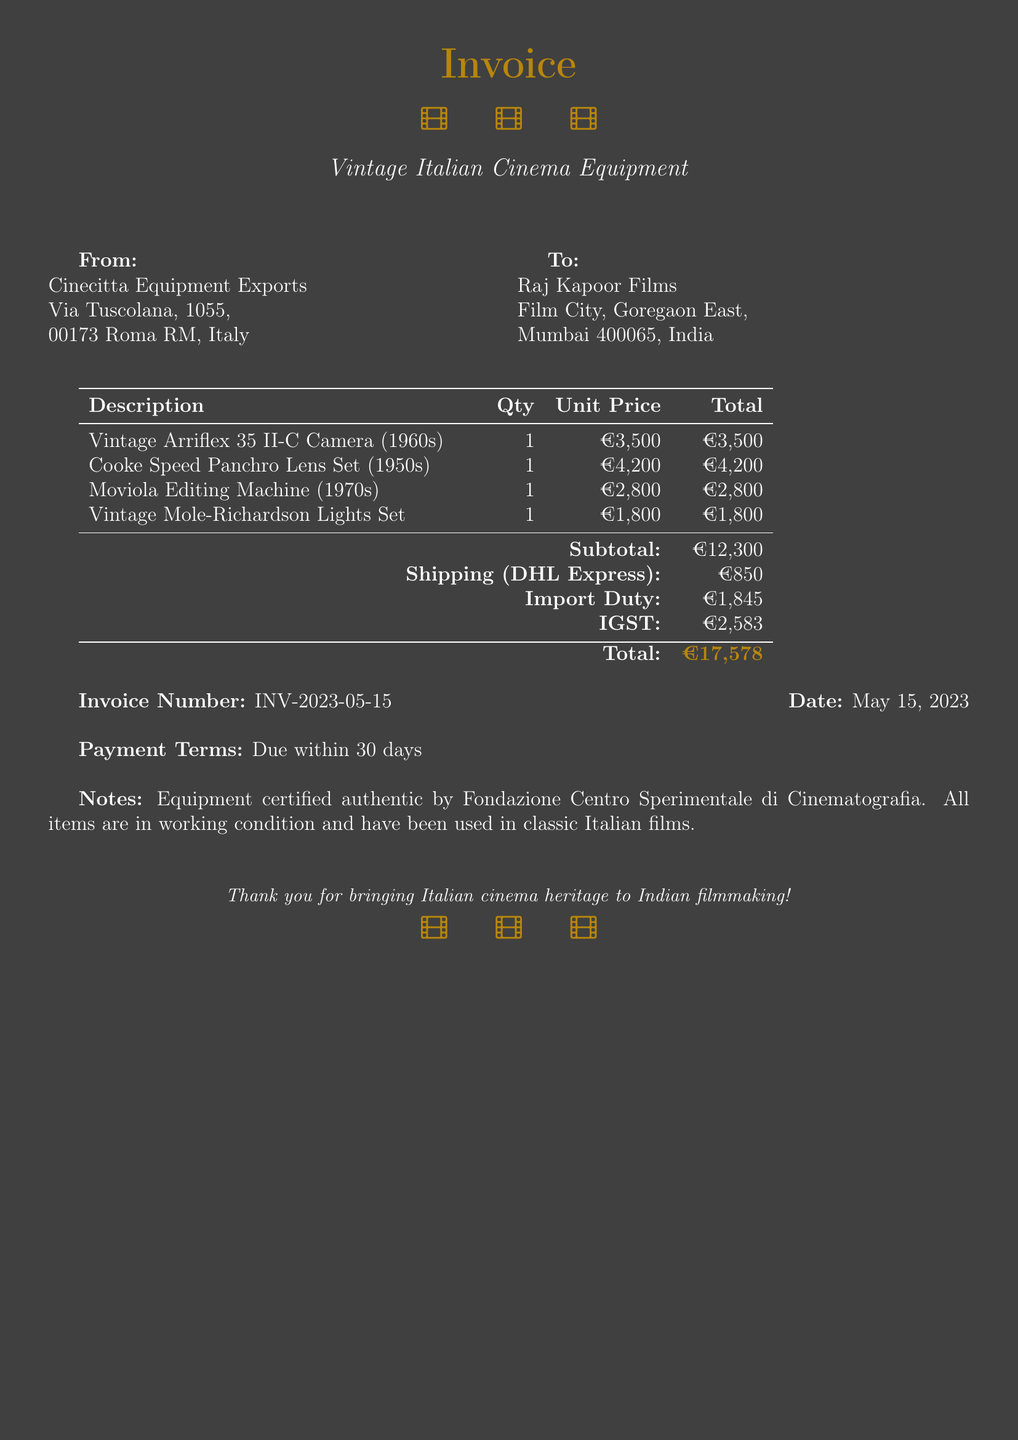What is the invoice number? The invoice number is a unique identifier for the transaction and can be found in the document.
Answer: INV-2023-05-15 What is the total amount due? The total amount due is the final sum that needs to be paid, calculated from the subtotal, shipping, import duty, and IGST.
Answer: €17,578 What is the date of the invoice? The date is when the invoice was issued, as specified in the document.
Answer: May 15, 2023 Who is the supplier of the equipment? The supplier is the company providing the vintage film equipment, mentioned at the top of the document.
Answer: Cinecitta Equipment Exports What is the shipping method used? The shipping method refers to the courier service used for delivery, which is detailed in the document.
Answer: DHL Express What is the subtotal before taxes and fees? The subtotal is the sum of all equipment costs before additional fees like shipping and taxes.
Answer: €12,300 How much is the import duty? The import duty is an additional cost for importing goods from abroad, detailed in the invoice.
Answer: €1,845 What payment term is specified? The payment term outlines the conditions for payment, which is usually the due date for the invoice amount.
Answer: Due within 30 days What items are certified authentic? The specific certification indicates the items have been verified for authenticity by an organization noted in the document.
Answer: Equipment certified authentic by Fondazione Centro Sperimentale di Cinematografia 